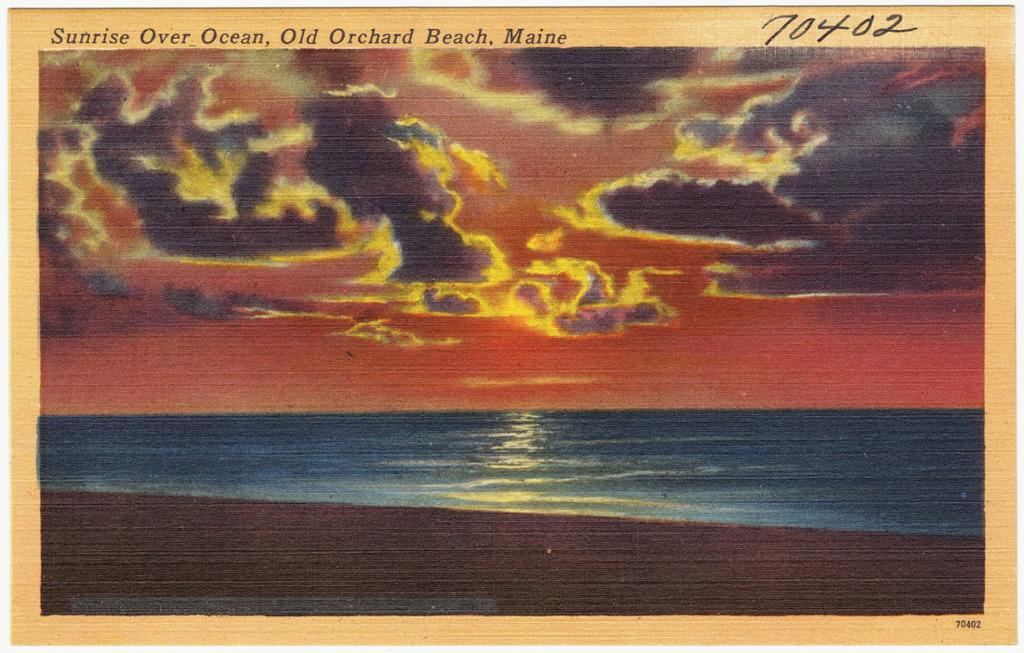<image>
Describe the image concisely. A painting of a sunrise as seen from Old Orchard Beach. 